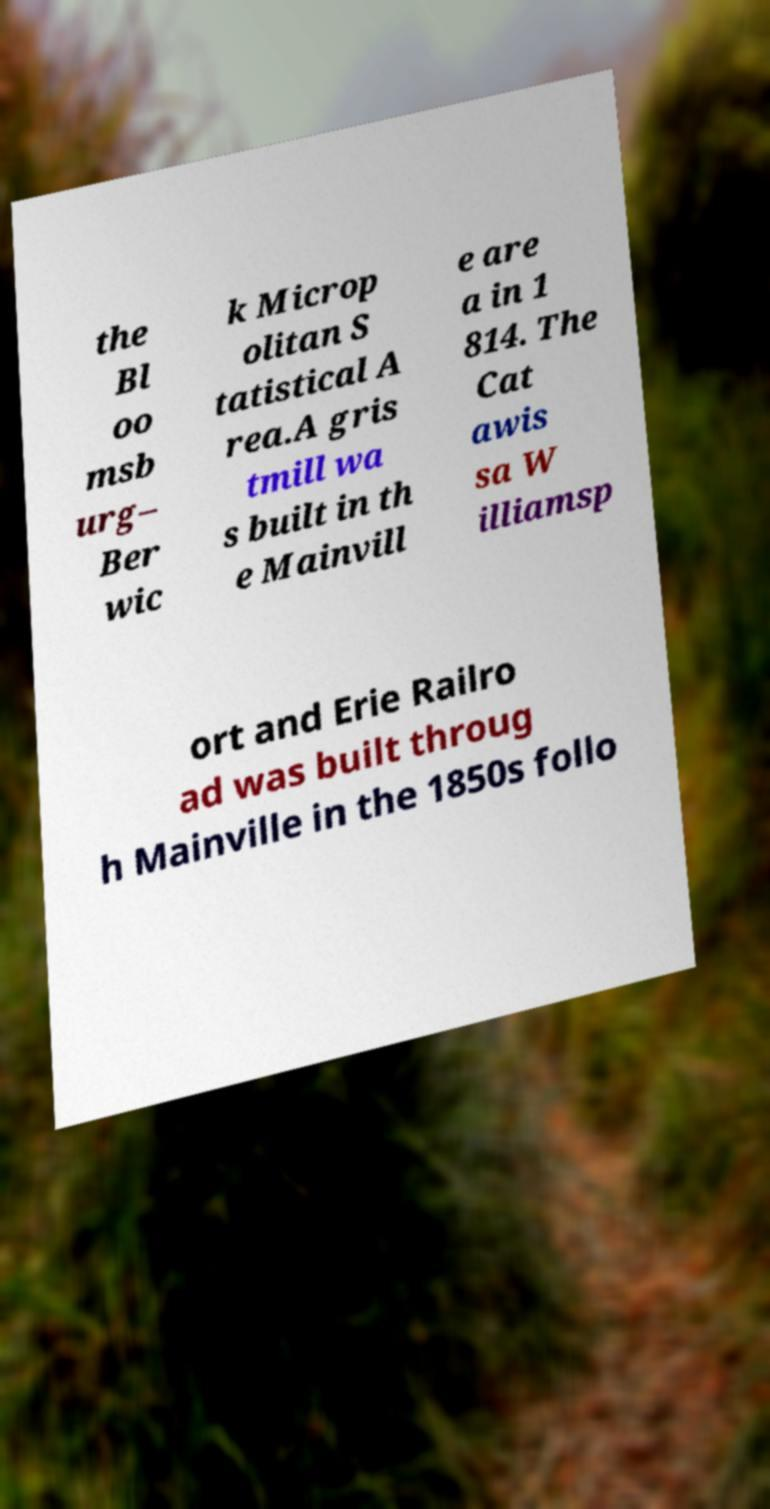What messages or text are displayed in this image? I need them in a readable, typed format. the Bl oo msb urg– Ber wic k Microp olitan S tatistical A rea.A gris tmill wa s built in th e Mainvill e are a in 1 814. The Cat awis sa W illiamsp ort and Erie Railro ad was built throug h Mainville in the 1850s follo 